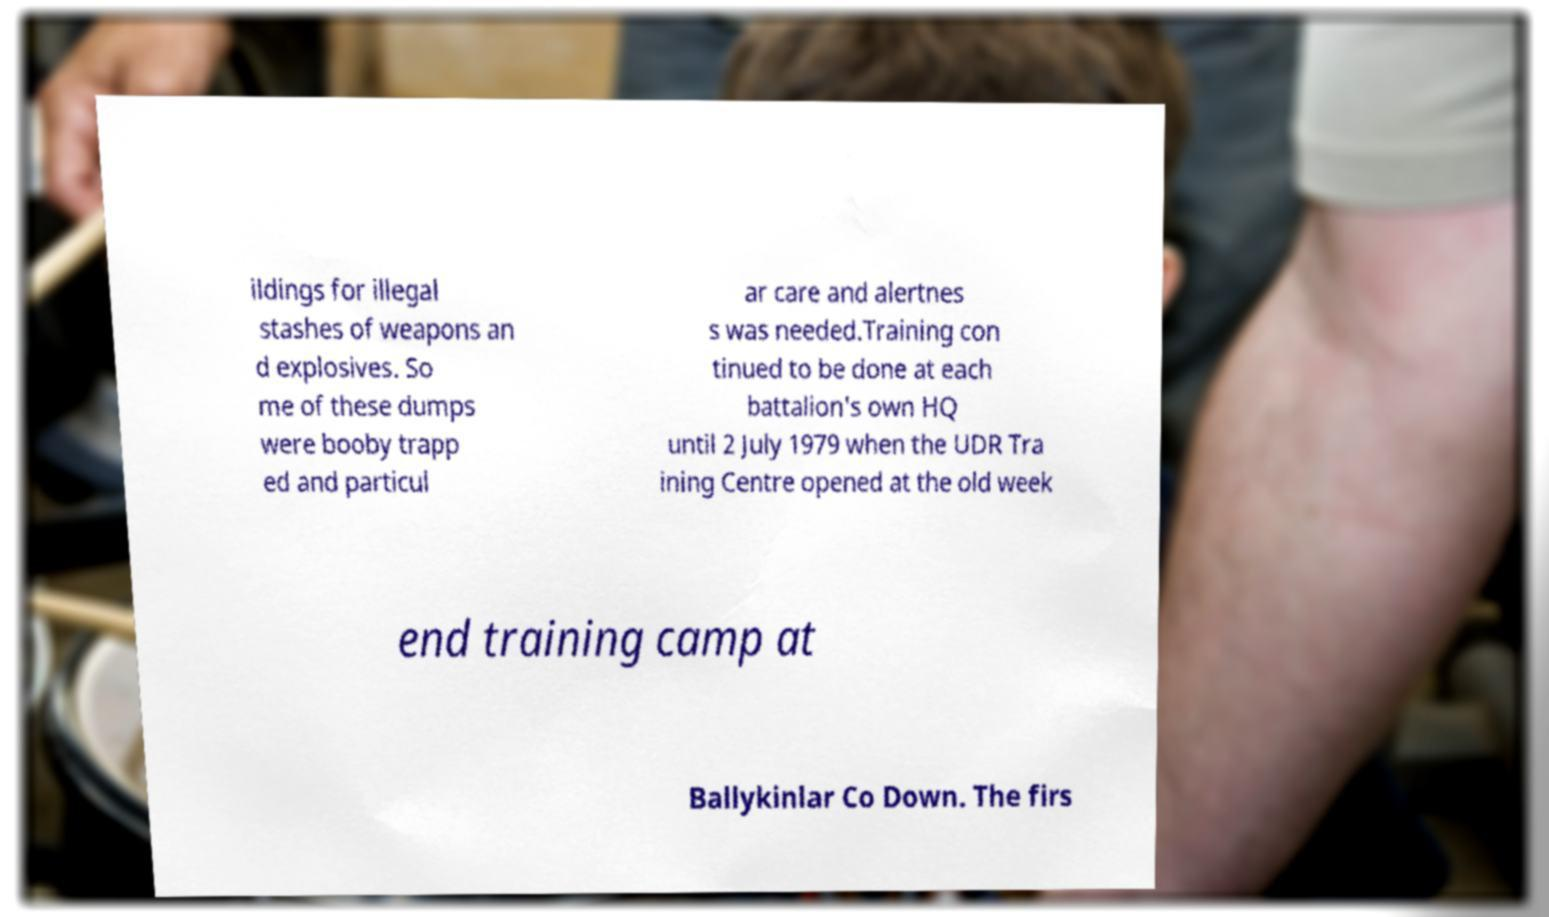What messages or text are displayed in this image? I need them in a readable, typed format. ildings for illegal stashes of weapons an d explosives. So me of these dumps were booby trapp ed and particul ar care and alertnes s was needed.Training con tinued to be done at each battalion's own HQ until 2 July 1979 when the UDR Tra ining Centre opened at the old week end training camp at Ballykinlar Co Down. The firs 